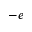<formula> <loc_0><loc_0><loc_500><loc_500>- e</formula> 